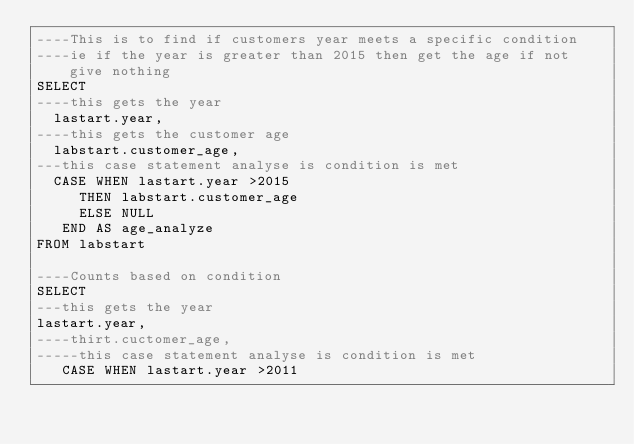<code> <loc_0><loc_0><loc_500><loc_500><_SQL_>----This is to find if customers year meets a specific condition
----ie if the year is greater than 2015 then get the age if not give nothing
SELECT
----this gets the year
  lastart.year,
----this gets the customer age
  labstart.customer_age,
---this case statement analyse is condition is met
  CASE WHEN lastart.year >2015
     THEN labstart.customer_age
     ELSE NULL
   END AS age_analyze
FROM labstart

----Counts based on condition
SELECT
---this gets the year
lastart.year,
----thirt.cuctomer_age,
-----this case statement analyse is condition is met
   CASE WHEN lastart.year >2011</code> 